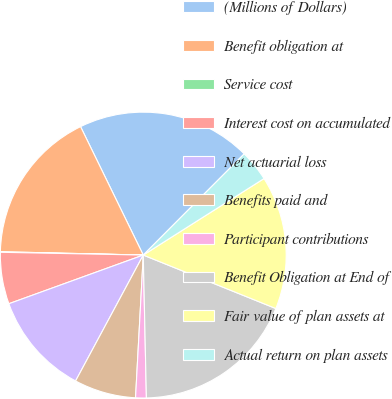<chart> <loc_0><loc_0><loc_500><loc_500><pie_chart><fcel>(Millions of Dollars)<fcel>Benefit obligation at<fcel>Service cost<fcel>Interest cost on accumulated<fcel>Net actuarial loss<fcel>Benefits paid and<fcel>Participant contributions<fcel>Benefit Obligation at End of<fcel>Fair value of plan assets at<fcel>Actual return on plan assets<nl><fcel>19.71%<fcel>17.4%<fcel>0.06%<fcel>5.84%<fcel>11.62%<fcel>6.99%<fcel>1.21%<fcel>18.55%<fcel>15.09%<fcel>3.53%<nl></chart> 